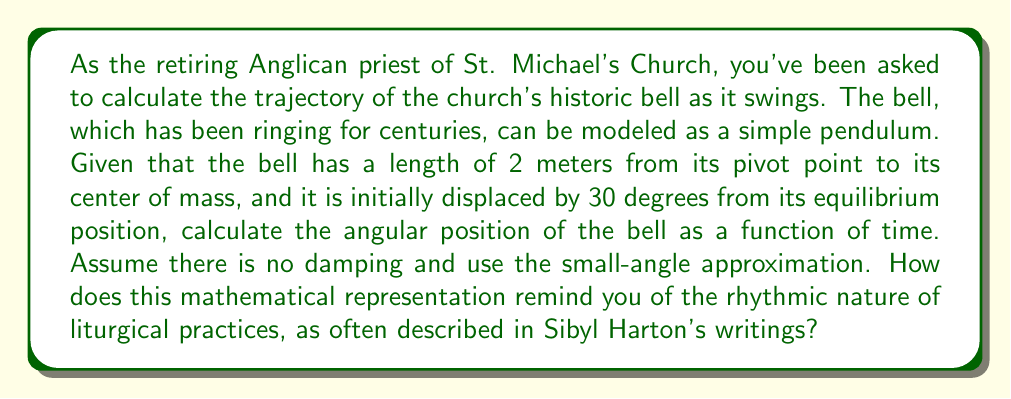Help me with this question. To solve this problem, we'll use the differential equation for simple harmonic motion, which describes the motion of a pendulum under small-angle approximation:

$$\frac{d^2\theta}{dt^2} + \frac{g}{L}\theta = 0$$

Where:
$\theta$ is the angular displacement
$t$ is time
$g$ is the acceleration due to gravity (approximately 9.8 m/s²)
$L$ is the length of the pendulum

1) First, we identify our parameters:
   $L = 2$ meters
   Initial angle $\theta_0 = 30° = \frac{\pi}{6}$ radians

2) The general solution to this differential equation is:

   $$\theta(t) = A \cos(\omega t) + B \sin(\omega t)$$

   Where $\omega = \sqrt{\frac{g}{L}}$ is the angular frequency.

3) Calculate $\omega$:
   $$\omega = \sqrt{\frac{9.8}{2}} \approx 2.21 \text{ rad/s}$$

4) Use initial conditions to find A and B:
   At $t=0$, $\theta = \frac{\pi}{6}$, so $A = \frac{\pi}{6}$
   At $t=0$, $\frac{d\theta}{dt} = 0$, so $B = 0$

5) Therefore, our solution is:

   $$\theta(t) = \frac{\pi}{6} \cos(2.21t)$$

This equation represents the rhythmic swinging of the bell, much like the cyclical nature of liturgical practices. The cosine function creates a repeating pattern, reminiscent of the recurring themes in church rituals and the changing seasons of the liturgical year, often explored in Sibyl Harton's writings.
Answer: $$\theta(t) = \frac{\pi}{6} \cos(2.21t)$$
Where $\theta$ is in radians and $t$ is in seconds. 